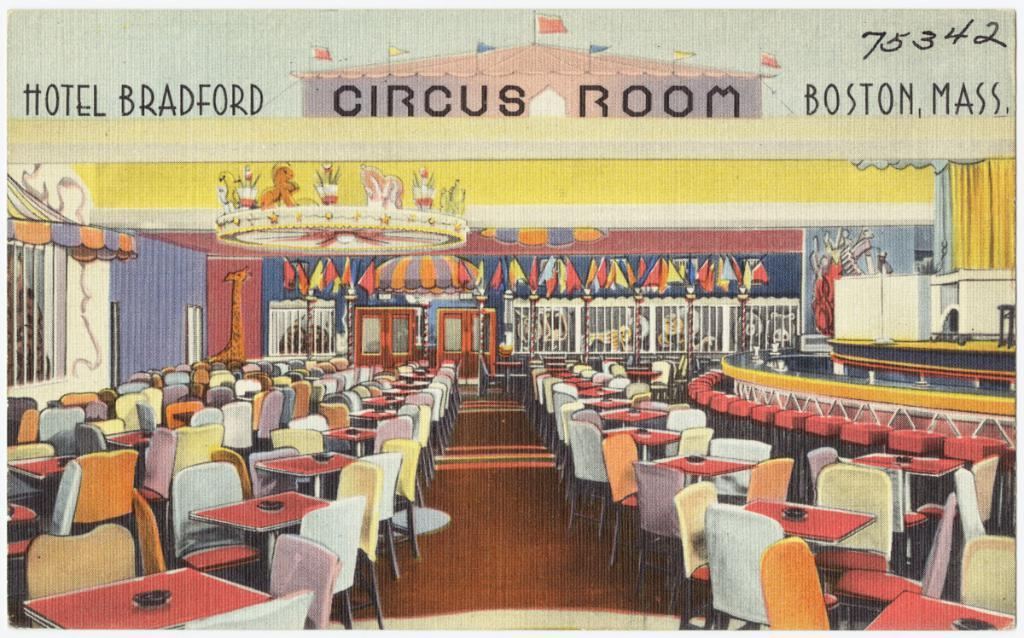What type of visual representation is the image? The image is a poster. What type of furniture can be seen in the image? There are chairs and tables in the image. What part of the room is visible in the image? The floor is visible in the image. What architectural features are present in the image? There are doors, walls, and grills in the image. What is written or displayed at the top of the image? There is text, flags, and numbers at the top of the image. How far away is the humor in the image? There is no humor present in the image; it is a poster featuring chairs, tables, doors, walls, grills, text, flags, and numbers. What is the balance of the grills in the image? The balance of the grills is not mentioned or depicted in the image; they are simply present as part of the scene. 